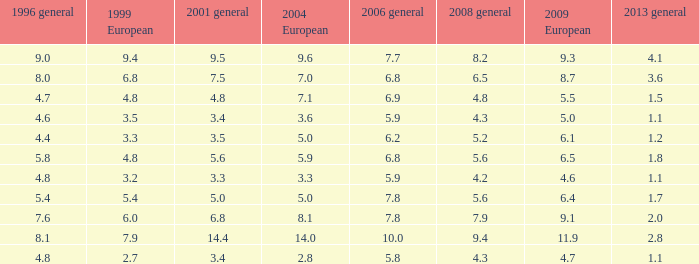How many values for 1999 European correspond to a value more than 4.7 in 2009 European, general 2001 more than 7.5, 2006 general at 10, and more than 9.4 in general 2008? 0.0. 